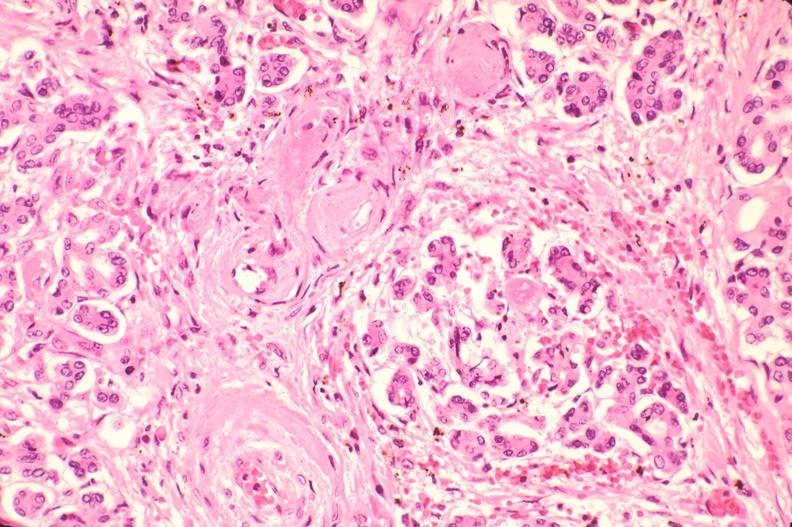s endocrine present?
Answer the question using a single word or phrase. Yes 